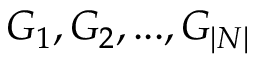<formula> <loc_0><loc_0><loc_500><loc_500>G _ { 1 } , G _ { 2 } , \dots , G _ { | N | }</formula> 